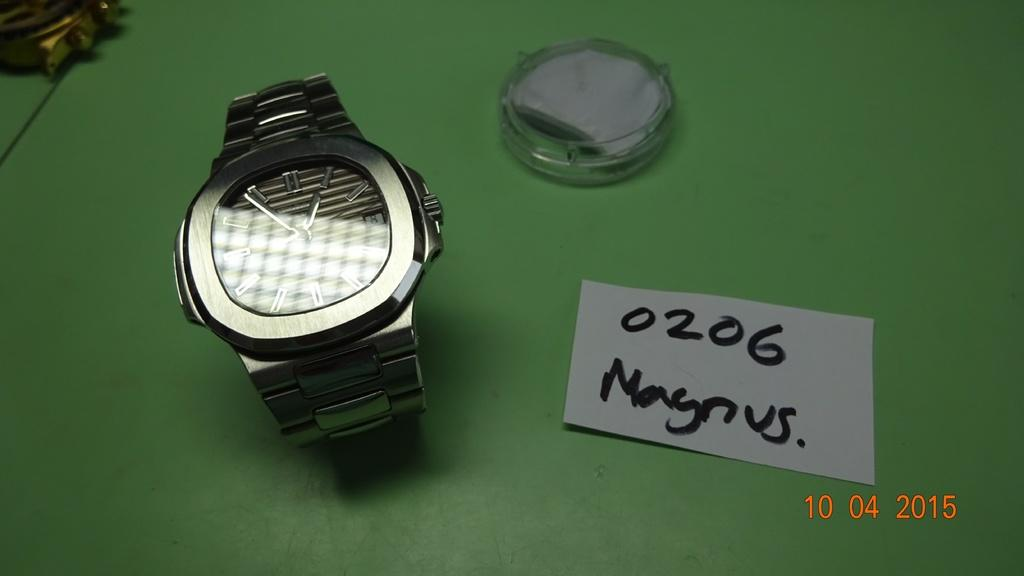What type of furniture is present in the image? There is a table in the image. What is the color of the table? The table is green. What object can be seen on the table? There is a watch on the table. Where is the paper located in relation to the table? The paper is on the right side of the table. What type of house is depicted on the canvas in the image? There is no canvas or house present in the image. 